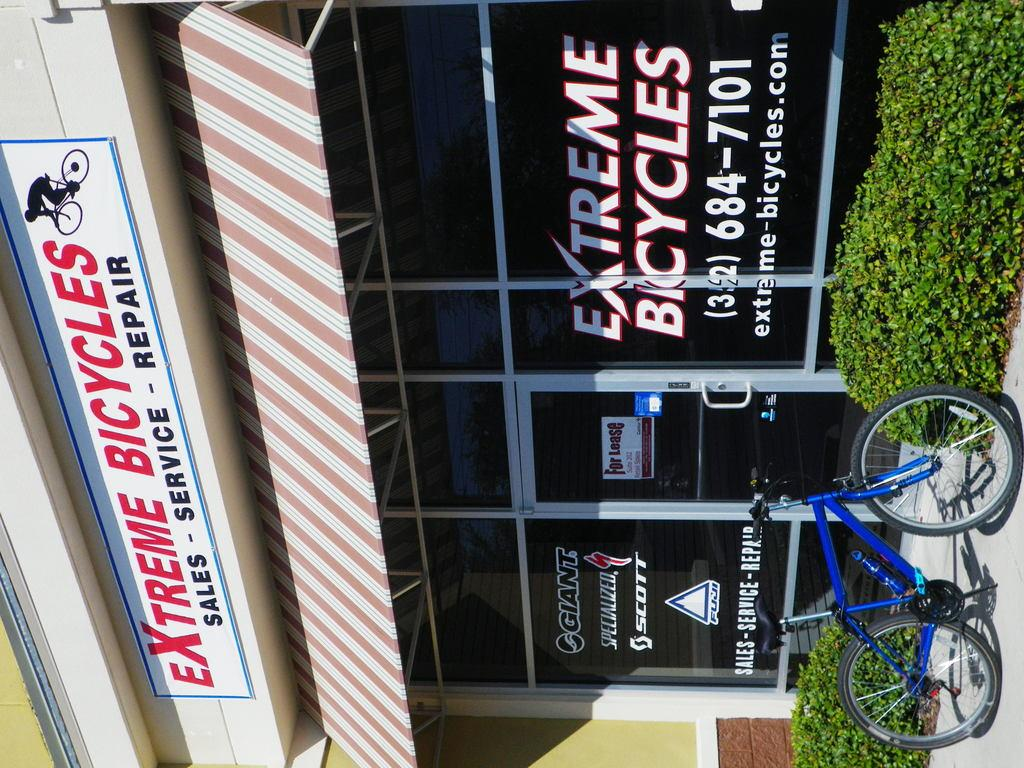What type of establishment is shown in the image? There is a shop in the image. What is the door of the shop made of? The door of the shop is made of glass. What can be seen to the left of the door? There is a board to the left of the door. What is parked to the right of the door? There is a bicycle parked to the right of the door. What type of vegetation is present in the image? There are small plants in the image. What type of paper is being used to rake the plants in the image? There is no paper or raking activity present in the image. The plants are small and not being tended to in any way. 